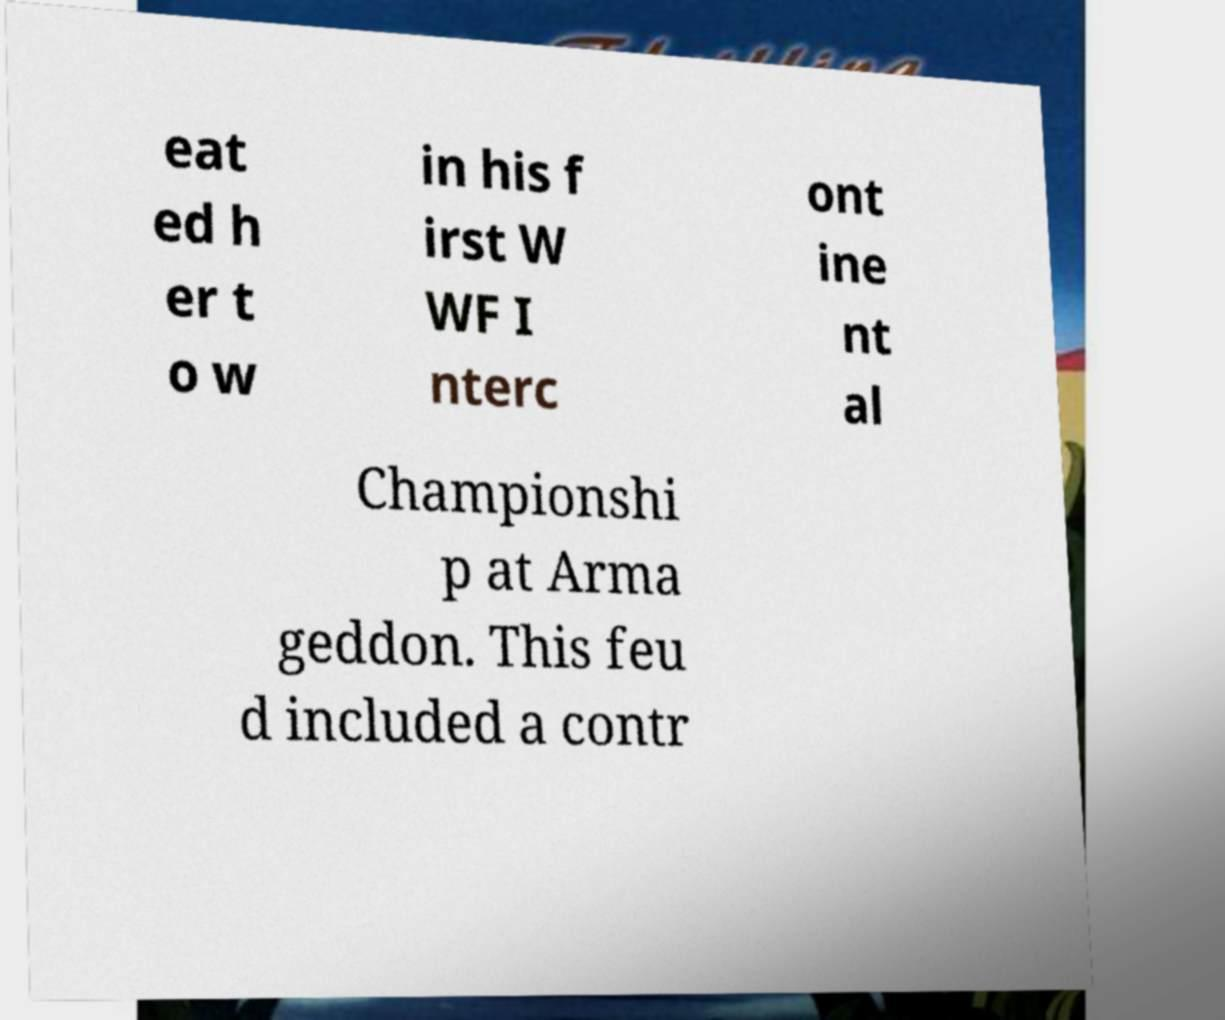Please identify and transcribe the text found in this image. eat ed h er t o w in his f irst W WF I nterc ont ine nt al Championshi p at Arma geddon. This feu d included a contr 